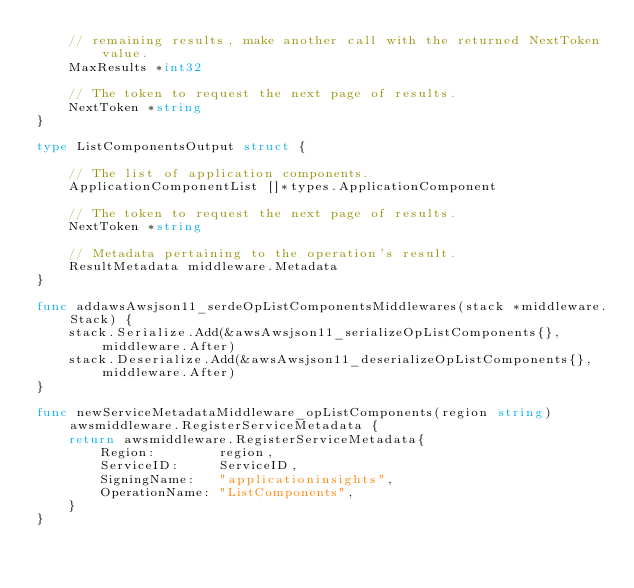Convert code to text. <code><loc_0><loc_0><loc_500><loc_500><_Go_>	// remaining results, make another call with the returned NextToken value.
	MaxResults *int32

	// The token to request the next page of results.
	NextToken *string
}

type ListComponentsOutput struct {

	// The list of application components.
	ApplicationComponentList []*types.ApplicationComponent

	// The token to request the next page of results.
	NextToken *string

	// Metadata pertaining to the operation's result.
	ResultMetadata middleware.Metadata
}

func addawsAwsjson11_serdeOpListComponentsMiddlewares(stack *middleware.Stack) {
	stack.Serialize.Add(&awsAwsjson11_serializeOpListComponents{}, middleware.After)
	stack.Deserialize.Add(&awsAwsjson11_deserializeOpListComponents{}, middleware.After)
}

func newServiceMetadataMiddleware_opListComponents(region string) awsmiddleware.RegisterServiceMetadata {
	return awsmiddleware.RegisterServiceMetadata{
		Region:        region,
		ServiceID:     ServiceID,
		SigningName:   "applicationinsights",
		OperationName: "ListComponents",
	}
}
</code> 